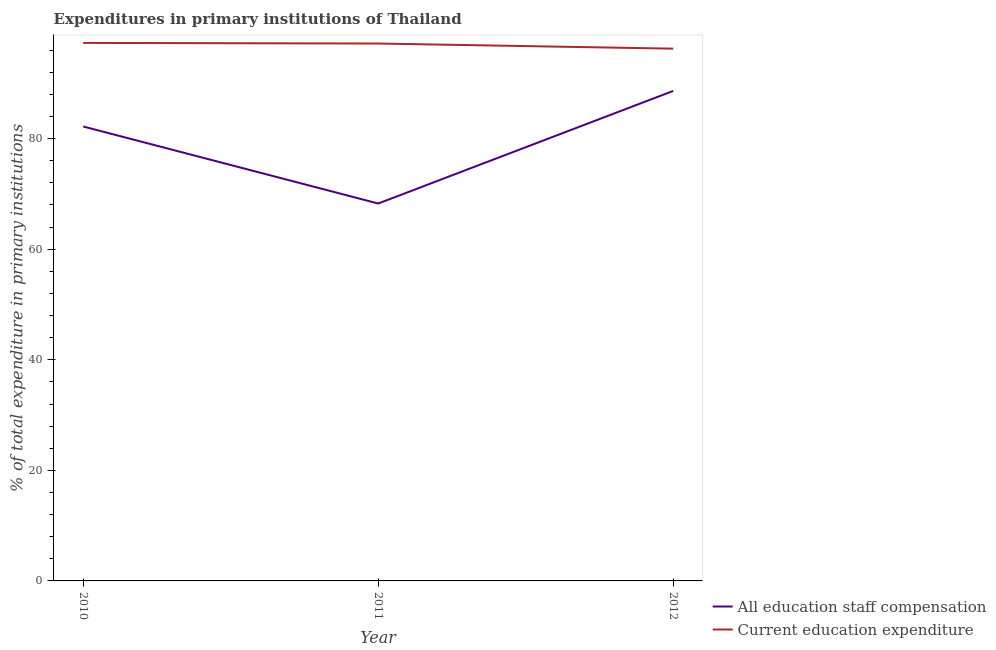How many different coloured lines are there?
Make the answer very short. 2. Does the line corresponding to expenditure in staff compensation intersect with the line corresponding to expenditure in education?
Your answer should be very brief. No. Is the number of lines equal to the number of legend labels?
Your answer should be compact. Yes. What is the expenditure in education in 2011?
Provide a short and direct response. 97.2. Across all years, what is the maximum expenditure in staff compensation?
Make the answer very short. 88.63. Across all years, what is the minimum expenditure in staff compensation?
Make the answer very short. 68.26. In which year was the expenditure in staff compensation maximum?
Offer a very short reply. 2012. What is the total expenditure in education in the graph?
Your response must be concise. 290.79. What is the difference between the expenditure in education in 2010 and that in 2012?
Keep it short and to the point. 1.04. What is the difference between the expenditure in staff compensation in 2010 and the expenditure in education in 2011?
Keep it short and to the point. -15. What is the average expenditure in staff compensation per year?
Make the answer very short. 79.7. In the year 2012, what is the difference between the expenditure in education and expenditure in staff compensation?
Ensure brevity in your answer.  7.65. What is the ratio of the expenditure in staff compensation in 2011 to that in 2012?
Provide a short and direct response. 0.77. Is the expenditure in staff compensation in 2010 less than that in 2011?
Offer a terse response. No. Is the difference between the expenditure in education in 2010 and 2011 greater than the difference between the expenditure in staff compensation in 2010 and 2011?
Give a very brief answer. No. What is the difference between the highest and the second highest expenditure in staff compensation?
Give a very brief answer. 6.43. What is the difference between the highest and the lowest expenditure in education?
Your answer should be compact. 1.04. Is the expenditure in staff compensation strictly greater than the expenditure in education over the years?
Offer a very short reply. No. Is the expenditure in education strictly less than the expenditure in staff compensation over the years?
Keep it short and to the point. No. How many lines are there?
Offer a very short reply. 2. How many years are there in the graph?
Ensure brevity in your answer.  3. What is the difference between two consecutive major ticks on the Y-axis?
Ensure brevity in your answer.  20. Does the graph contain grids?
Make the answer very short. No. Where does the legend appear in the graph?
Your answer should be very brief. Bottom right. How are the legend labels stacked?
Your answer should be very brief. Vertical. What is the title of the graph?
Offer a very short reply. Expenditures in primary institutions of Thailand. What is the label or title of the Y-axis?
Provide a short and direct response. % of total expenditure in primary institutions. What is the % of total expenditure in primary institutions of All education staff compensation in 2010?
Provide a short and direct response. 82.2. What is the % of total expenditure in primary institutions of Current education expenditure in 2010?
Your response must be concise. 97.32. What is the % of total expenditure in primary institutions in All education staff compensation in 2011?
Make the answer very short. 68.26. What is the % of total expenditure in primary institutions of Current education expenditure in 2011?
Ensure brevity in your answer.  97.2. What is the % of total expenditure in primary institutions in All education staff compensation in 2012?
Give a very brief answer. 88.63. What is the % of total expenditure in primary institutions in Current education expenditure in 2012?
Offer a terse response. 96.28. Across all years, what is the maximum % of total expenditure in primary institutions in All education staff compensation?
Your response must be concise. 88.63. Across all years, what is the maximum % of total expenditure in primary institutions in Current education expenditure?
Make the answer very short. 97.32. Across all years, what is the minimum % of total expenditure in primary institutions of All education staff compensation?
Offer a terse response. 68.26. Across all years, what is the minimum % of total expenditure in primary institutions in Current education expenditure?
Your answer should be compact. 96.28. What is the total % of total expenditure in primary institutions in All education staff compensation in the graph?
Provide a short and direct response. 239.09. What is the total % of total expenditure in primary institutions in Current education expenditure in the graph?
Offer a very short reply. 290.79. What is the difference between the % of total expenditure in primary institutions in All education staff compensation in 2010 and that in 2011?
Your answer should be very brief. 13.93. What is the difference between the % of total expenditure in primary institutions in Current education expenditure in 2010 and that in 2011?
Make the answer very short. 0.11. What is the difference between the % of total expenditure in primary institutions in All education staff compensation in 2010 and that in 2012?
Make the answer very short. -6.43. What is the difference between the % of total expenditure in primary institutions of Current education expenditure in 2010 and that in 2012?
Provide a succinct answer. 1.04. What is the difference between the % of total expenditure in primary institutions of All education staff compensation in 2011 and that in 2012?
Your answer should be compact. -20.36. What is the difference between the % of total expenditure in primary institutions in Current education expenditure in 2011 and that in 2012?
Offer a terse response. 0.93. What is the difference between the % of total expenditure in primary institutions in All education staff compensation in 2010 and the % of total expenditure in primary institutions in Current education expenditure in 2011?
Your answer should be very brief. -15. What is the difference between the % of total expenditure in primary institutions in All education staff compensation in 2010 and the % of total expenditure in primary institutions in Current education expenditure in 2012?
Your response must be concise. -14.08. What is the difference between the % of total expenditure in primary institutions of All education staff compensation in 2011 and the % of total expenditure in primary institutions of Current education expenditure in 2012?
Provide a short and direct response. -28.01. What is the average % of total expenditure in primary institutions of All education staff compensation per year?
Your response must be concise. 79.7. What is the average % of total expenditure in primary institutions in Current education expenditure per year?
Give a very brief answer. 96.93. In the year 2010, what is the difference between the % of total expenditure in primary institutions in All education staff compensation and % of total expenditure in primary institutions in Current education expenditure?
Make the answer very short. -15.12. In the year 2011, what is the difference between the % of total expenditure in primary institutions of All education staff compensation and % of total expenditure in primary institutions of Current education expenditure?
Ensure brevity in your answer.  -28.94. In the year 2012, what is the difference between the % of total expenditure in primary institutions of All education staff compensation and % of total expenditure in primary institutions of Current education expenditure?
Your answer should be compact. -7.65. What is the ratio of the % of total expenditure in primary institutions of All education staff compensation in 2010 to that in 2011?
Provide a succinct answer. 1.2. What is the ratio of the % of total expenditure in primary institutions in All education staff compensation in 2010 to that in 2012?
Ensure brevity in your answer.  0.93. What is the ratio of the % of total expenditure in primary institutions in Current education expenditure in 2010 to that in 2012?
Your answer should be compact. 1.01. What is the ratio of the % of total expenditure in primary institutions of All education staff compensation in 2011 to that in 2012?
Ensure brevity in your answer.  0.77. What is the ratio of the % of total expenditure in primary institutions in Current education expenditure in 2011 to that in 2012?
Your answer should be compact. 1.01. What is the difference between the highest and the second highest % of total expenditure in primary institutions of All education staff compensation?
Your answer should be very brief. 6.43. What is the difference between the highest and the second highest % of total expenditure in primary institutions in Current education expenditure?
Offer a terse response. 0.11. What is the difference between the highest and the lowest % of total expenditure in primary institutions of All education staff compensation?
Give a very brief answer. 20.36. What is the difference between the highest and the lowest % of total expenditure in primary institutions of Current education expenditure?
Offer a terse response. 1.04. 